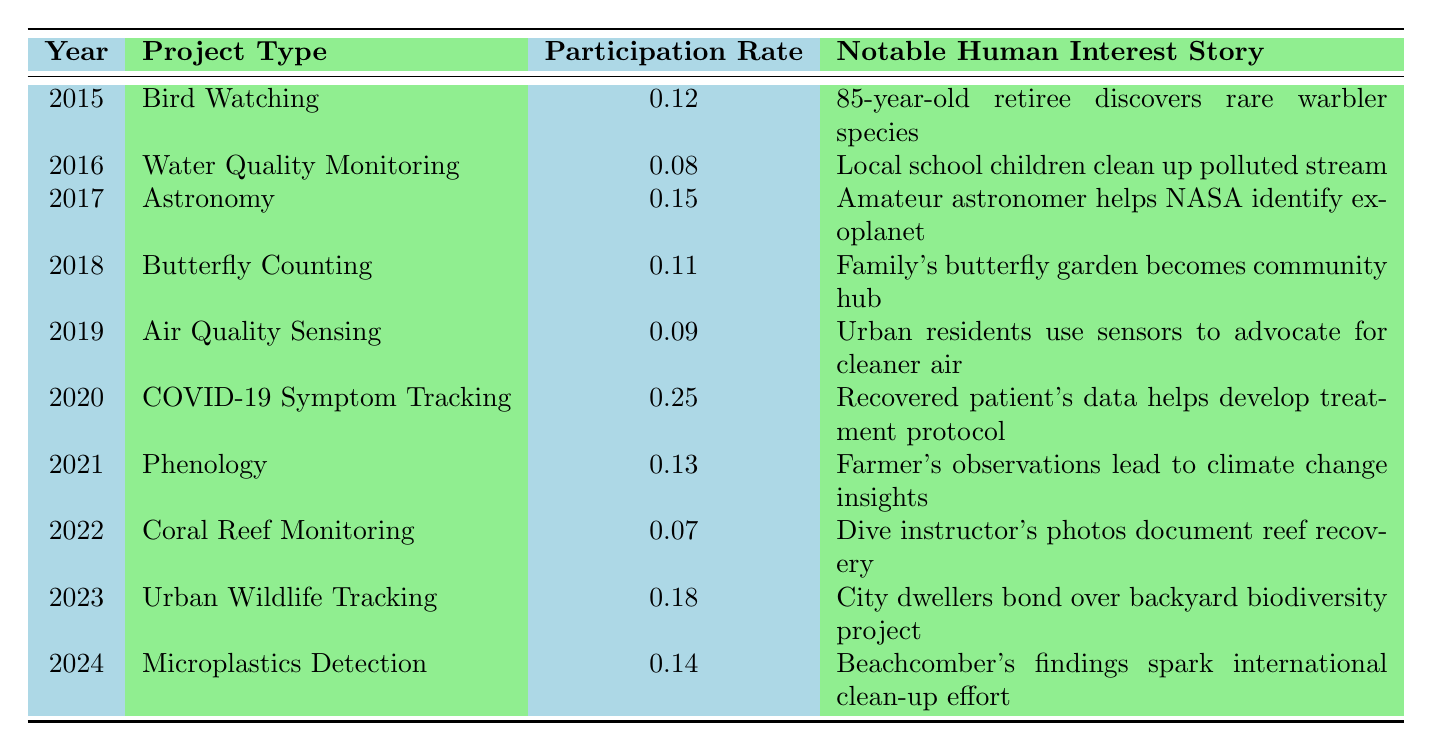What was the participation rate for Bird Watching in 2015? The table shows that the participation rate for Bird Watching in 2015 is 0.12.
Answer: 0.12 Which project had the highest participation rate, and what year was it? The highest participation rate is 0.25, which occurred in 2020 for the COVID-19 Symptom Tracking project.
Answer: COVID-19 Symptom Tracking, 2020 How many projects had a participation rate below 0.10? By reviewing the participation rates in the table, Water Quality Monitoring (0.08), Coral Reef Monitoring (0.07), and Air Quality Sensing (0.09) all have rates below 0.10, totaling three projects.
Answer: 3 What is the average participation rate for all projects listed from 2015 to 2024? The participation rates are 0.12, 0.08, 0.15, 0.11, 0.09, 0.25, 0.13, 0.07, 0.18, and 0.14. Adding them up gives 1.14, and dividing by 10 (the number of projects) yields an average of 0.114.
Answer: 0.114 Did any project remain consistent in its participation rate year-over-year? The participation rates varied each year without any project showing consistency, as they all changed from year to year.
Answer: No Which project type had the lowest participation rate, and what notable human interest story is associated with it? The project with the lowest participation rate is Coral Reef Monitoring (0.07), and the associated human interest story is about a dive instructor documenting reef recovery.
Answer: Coral Reef Monitoring, dive instructor's photos document reef recovery What was the difference in participation rates between the highest (COVID-19 Symptom Tracking) and the lowest (Coral Reef Monitoring)? The highest rate is 0.25 for COVID-19 Symptom Tracking and the lowest is 0.07 for Coral Reef Monitoring. The difference is 0.25 - 0.07 = 0.18.
Answer: 0.18 Which years saw a participation rate above 0.15? The years with participation rates above 0.15 are 2017 (0.15) and 2020 (0.25).
Answer: 2017, 2020 How many notable stories involved community engagement? The notable stories reflecting community engagement include the school children cleaning up a stream, urban residents advocating for cleaner air, and city dwellers bonding over a biodiversity project. Counting these results in three stories.
Answer: 3 What trend can be observed in participation rates from 2015 to 2024? The participation rates fluctuated over the years, with a noticeable spike in 2020 for COVID-19 Symptom Tracking, contrasted against earlier years, and then a decline in subsequent years.
Answer: Fluctuating trend with a peak in 2020 